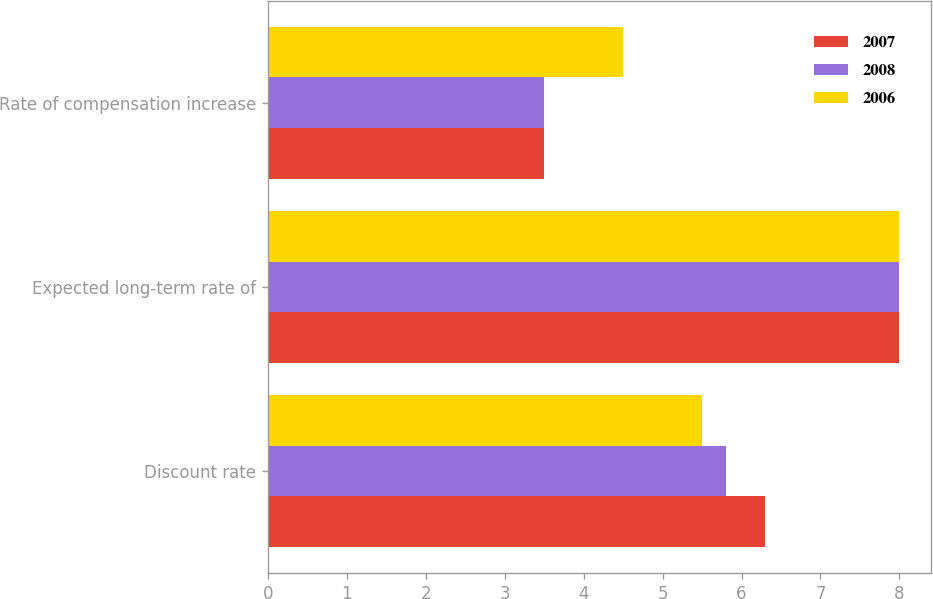Convert chart to OTSL. <chart><loc_0><loc_0><loc_500><loc_500><stacked_bar_chart><ecel><fcel>Discount rate<fcel>Expected long-term rate of<fcel>Rate of compensation increase<nl><fcel>2007<fcel>6.3<fcel>8<fcel>3.5<nl><fcel>2008<fcel>5.8<fcel>8<fcel>3.5<nl><fcel>2006<fcel>5.5<fcel>8<fcel>4.5<nl></chart> 